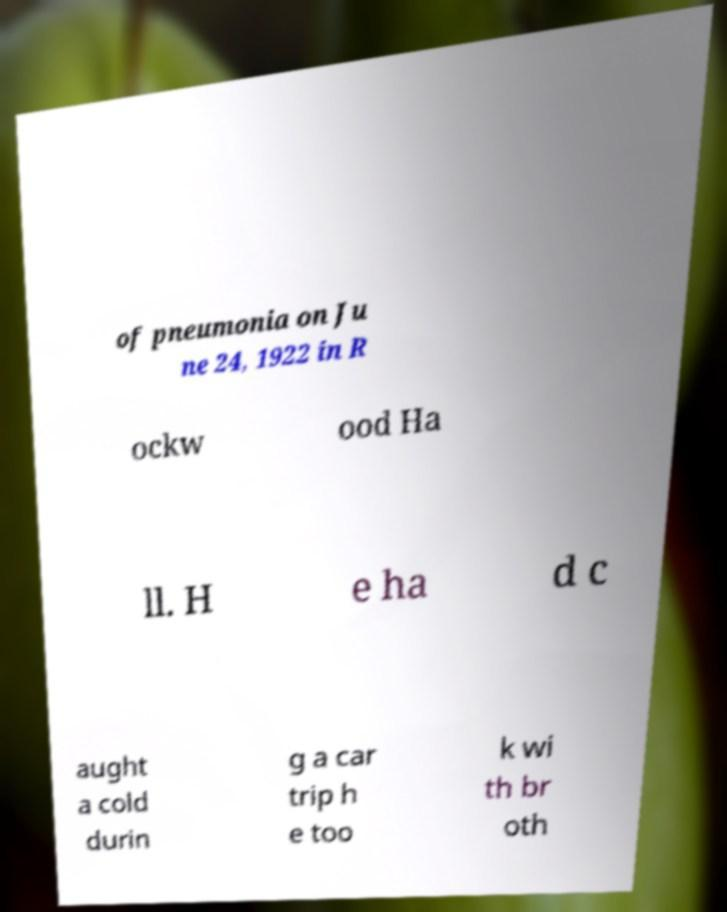I need the written content from this picture converted into text. Can you do that? of pneumonia on Ju ne 24, 1922 in R ockw ood Ha ll. H e ha d c aught a cold durin g a car trip h e too k wi th br oth 